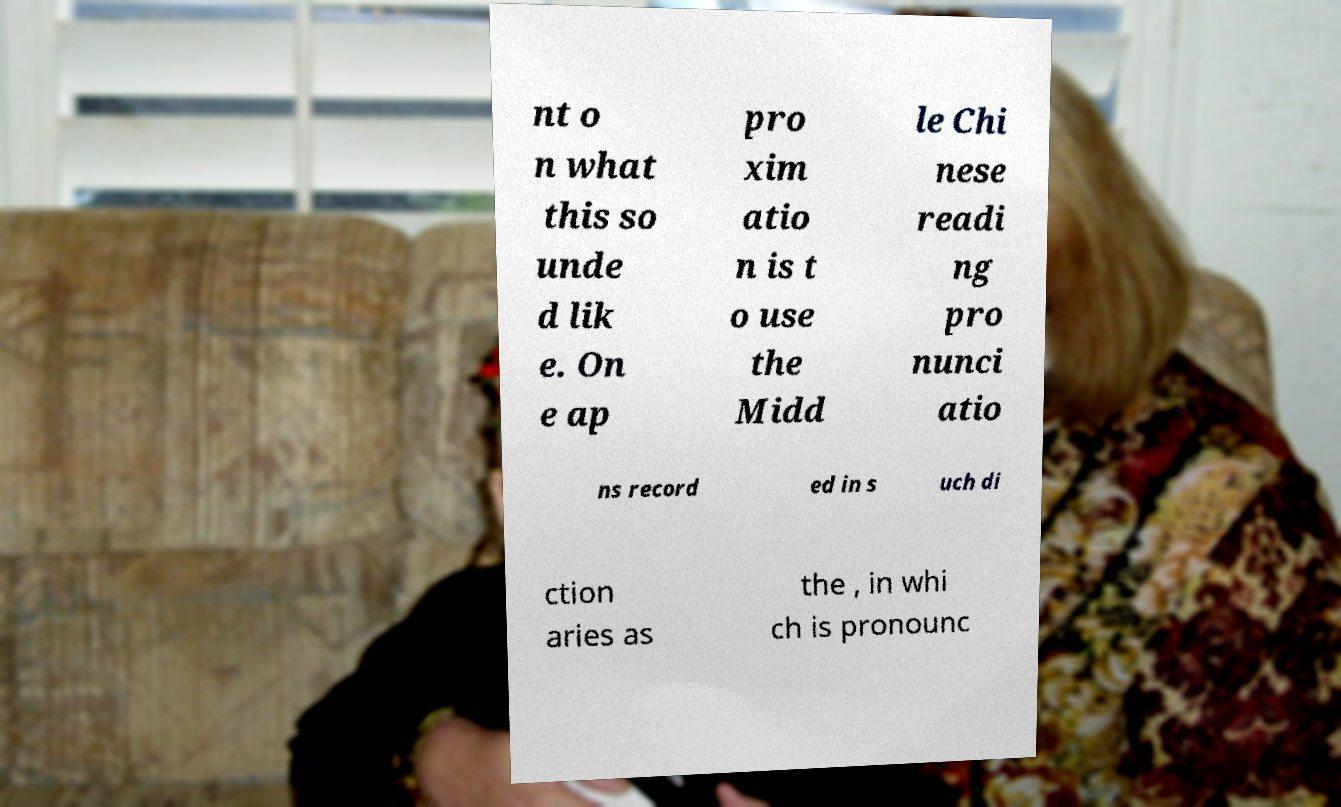Please identify and transcribe the text found in this image. nt o n what this so unde d lik e. On e ap pro xim atio n is t o use the Midd le Chi nese readi ng pro nunci atio ns record ed in s uch di ction aries as the , in whi ch is pronounc 